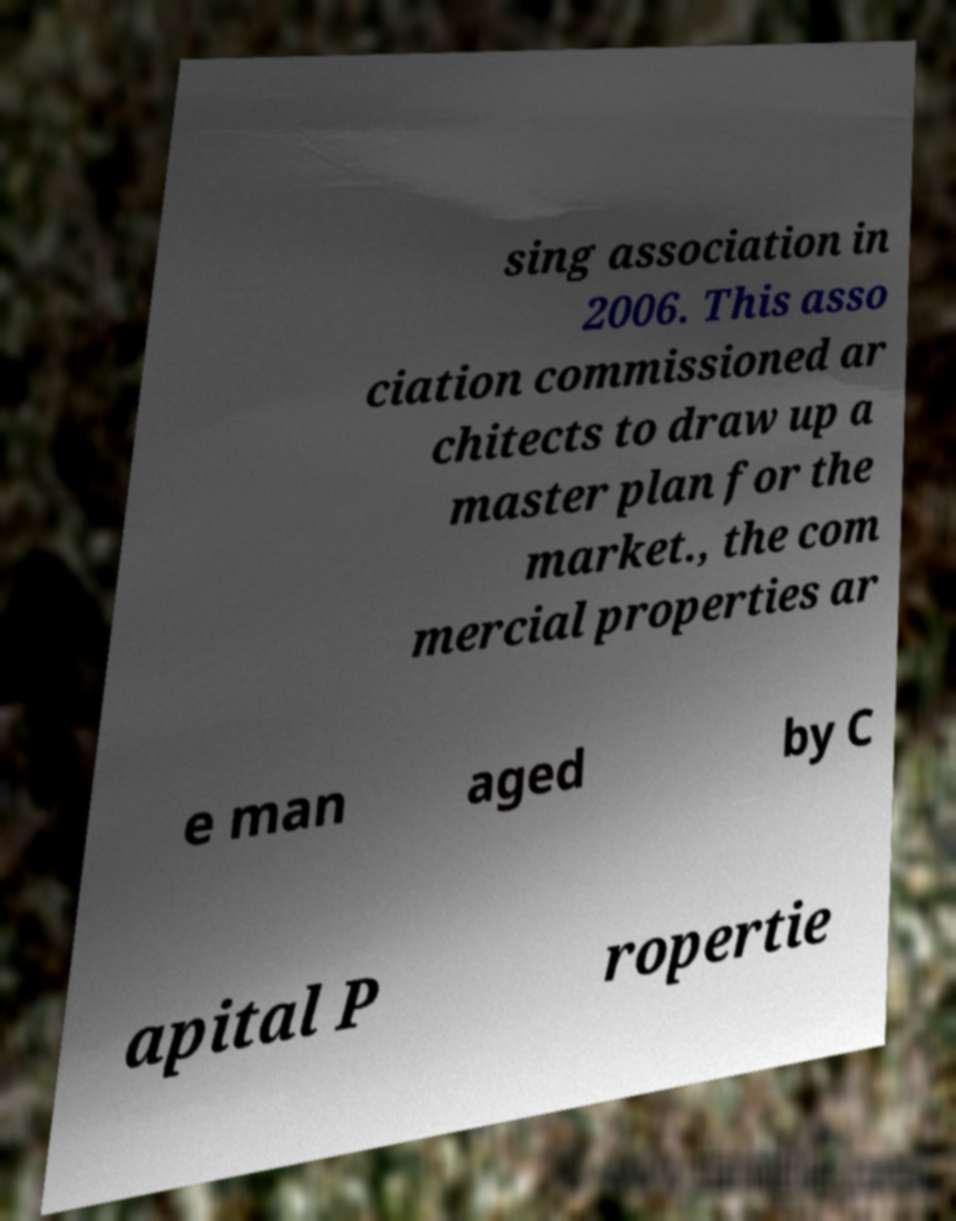Please identify and transcribe the text found in this image. sing association in 2006. This asso ciation commissioned ar chitects to draw up a master plan for the market., the com mercial properties ar e man aged by C apital P ropertie 